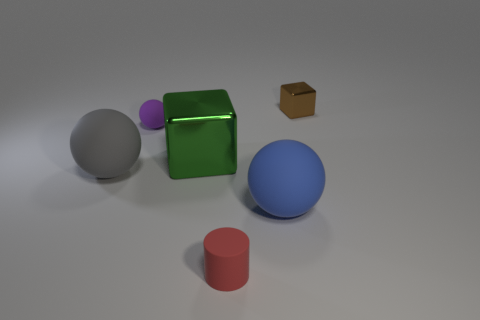Subtract all gray rubber balls. How many balls are left? 2 Subtract all gray spheres. How many spheres are left? 2 Add 3 green metal blocks. How many objects exist? 9 Subtract all cylinders. How many objects are left? 5 Subtract all cyan cubes. Subtract all gray cylinders. How many cubes are left? 2 Subtract all purple cylinders. How many red balls are left? 0 Subtract all large blue balls. Subtract all big metallic things. How many objects are left? 4 Add 5 green metal things. How many green metal things are left? 6 Add 4 big gray rubber things. How many big gray rubber things exist? 5 Subtract 0 cyan blocks. How many objects are left? 6 